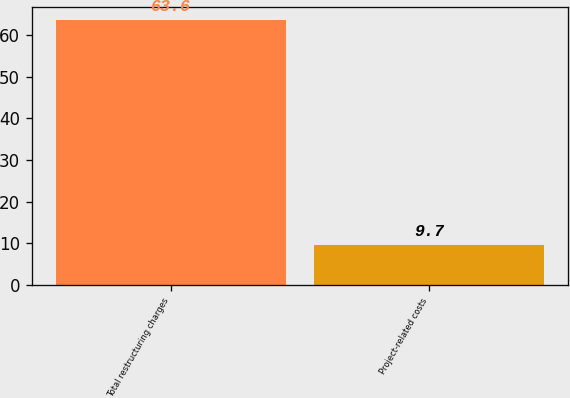<chart> <loc_0><loc_0><loc_500><loc_500><bar_chart><fcel>Total restructuring charges<fcel>Project-related costs<nl><fcel>63.6<fcel>9.7<nl></chart> 